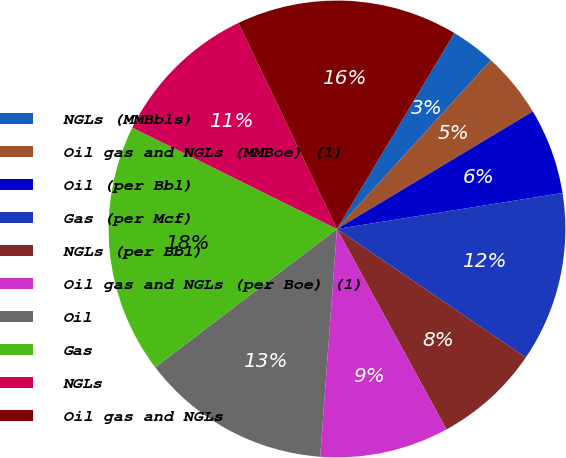Convert chart. <chart><loc_0><loc_0><loc_500><loc_500><pie_chart><fcel>NGLs (MMBbls)<fcel>Oil gas and NGLs (MMBoe) (1)<fcel>Oil (per Bbl)<fcel>Gas (per Mcf)<fcel>NGLs (per Bbl)<fcel>Oil gas and NGLs (per Boe) (1)<fcel>Oil<fcel>Gas<fcel>NGLs<fcel>Oil gas and NGLs<nl><fcel>3.18%<fcel>4.63%<fcel>6.08%<fcel>12.03%<fcel>7.53%<fcel>9.13%<fcel>13.48%<fcel>17.67%<fcel>10.58%<fcel>15.69%<nl></chart> 